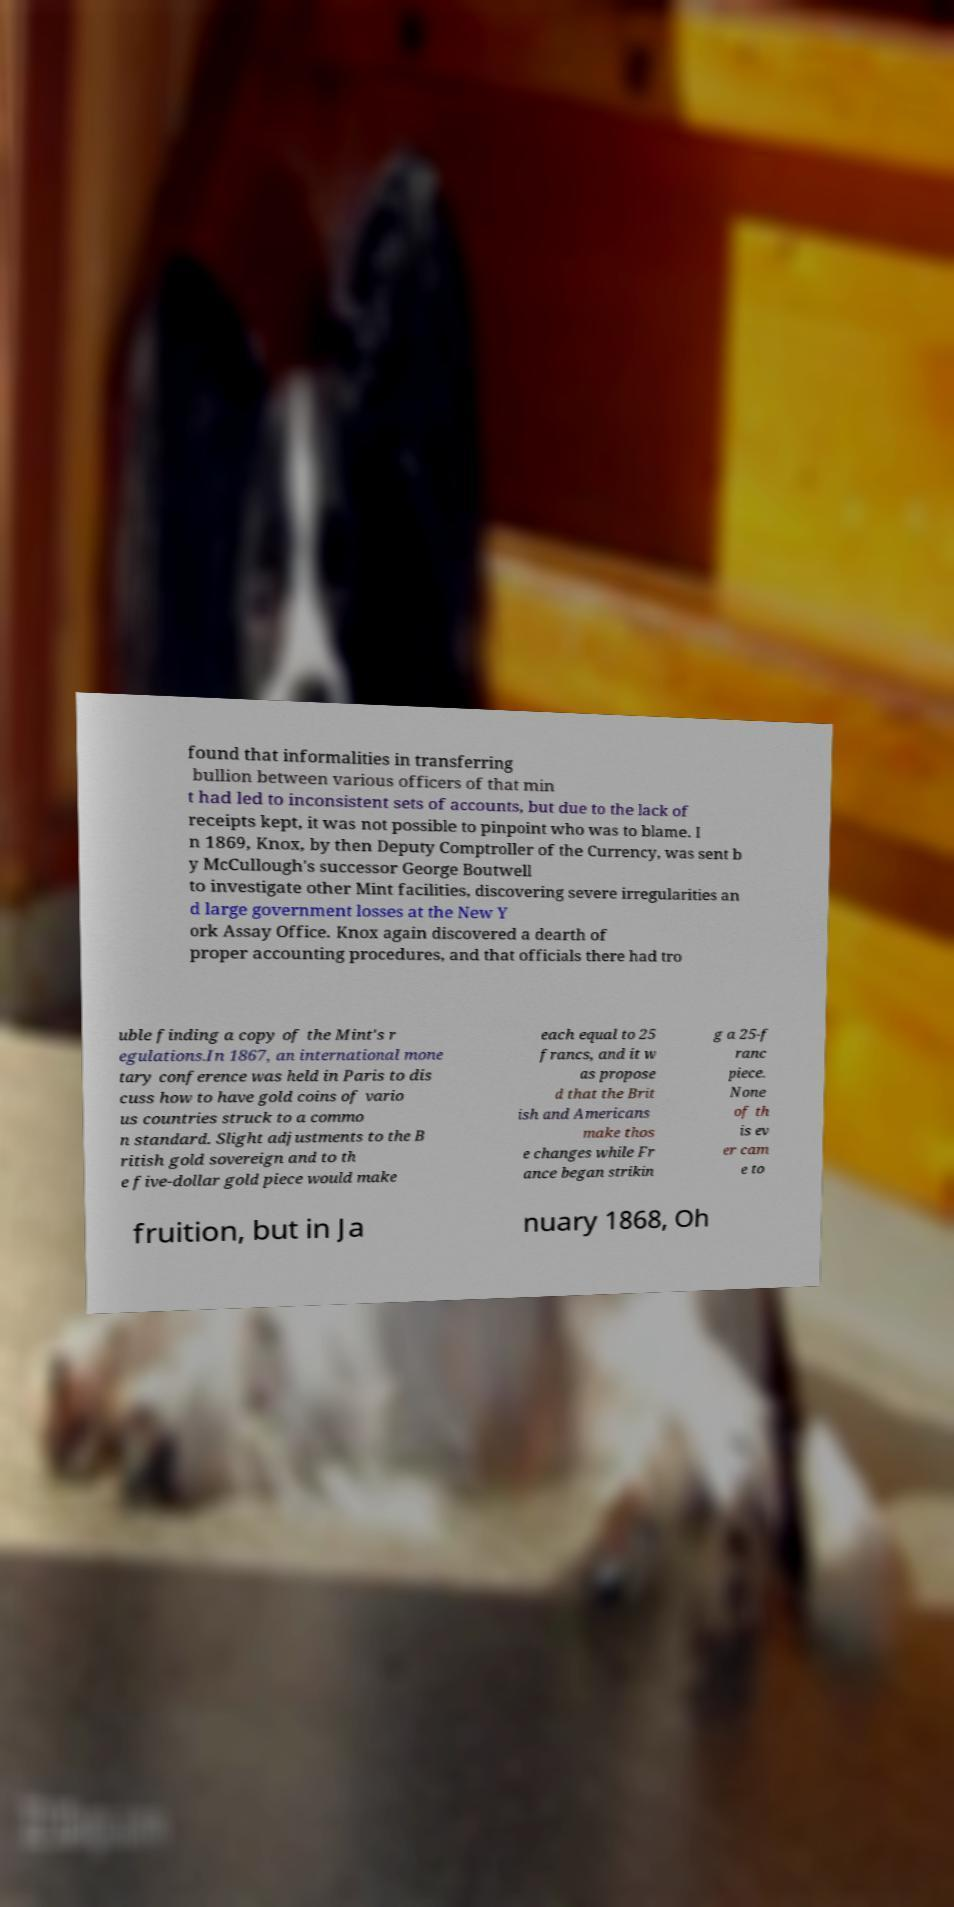Can you accurately transcribe the text from the provided image for me? found that informalities in transferring bullion between various officers of that min t had led to inconsistent sets of accounts, but due to the lack of receipts kept, it was not possible to pinpoint who was to blame. I n 1869, Knox, by then Deputy Comptroller of the Currency, was sent b y McCullough's successor George Boutwell to investigate other Mint facilities, discovering severe irregularities an d large government losses at the New Y ork Assay Office. Knox again discovered a dearth of proper accounting procedures, and that officials there had tro uble finding a copy of the Mint's r egulations.In 1867, an international mone tary conference was held in Paris to dis cuss how to have gold coins of vario us countries struck to a commo n standard. Slight adjustments to the B ritish gold sovereign and to th e five-dollar gold piece would make each equal to 25 francs, and it w as propose d that the Brit ish and Americans make thos e changes while Fr ance began strikin g a 25-f ranc piece. None of th is ev er cam e to fruition, but in Ja nuary 1868, Oh 